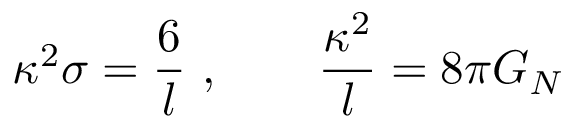<formula> <loc_0><loc_0><loc_500><loc_500>\kappa ^ { 2 } \sigma = { \frac { 6 } { l } } \ , \quad { \frac { \kappa ^ { 2 } } { l } } = 8 \pi G _ { N }</formula> 